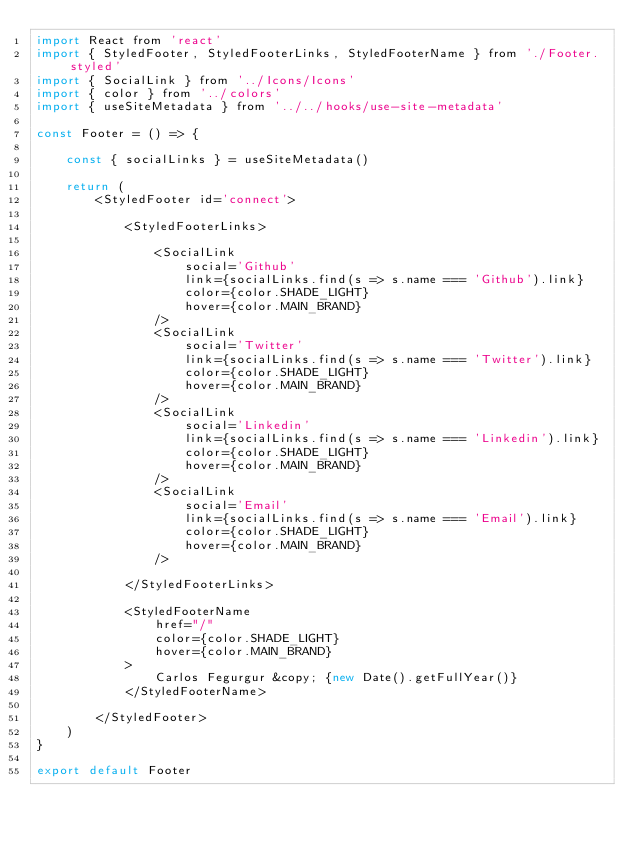<code> <loc_0><loc_0><loc_500><loc_500><_JavaScript_>import React from 'react'
import { StyledFooter, StyledFooterLinks, StyledFooterName } from './Footer.styled'
import { SocialLink } from '../Icons/Icons'
import { color } from '../colors'
import { useSiteMetadata } from '../../hooks/use-site-metadata'

const Footer = () => {

	const { socialLinks } = useSiteMetadata()

	return (
		<StyledFooter id='connect'>

			<StyledFooterLinks>

				<SocialLink
					social='Github'
					link={socialLinks.find(s => s.name === 'Github').link}
					color={color.SHADE_LIGHT}
					hover={color.MAIN_BRAND}
				/>
				<SocialLink
					social='Twitter'
					link={socialLinks.find(s => s.name === 'Twitter').link}
					color={color.SHADE_LIGHT}
					hover={color.MAIN_BRAND}
				/>
				<SocialLink
					social='Linkedin'
					link={socialLinks.find(s => s.name === 'Linkedin').link}
					color={color.SHADE_LIGHT}
					hover={color.MAIN_BRAND}
				/>
				<SocialLink
					social='Email'
					link={socialLinks.find(s => s.name === 'Email').link}
					color={color.SHADE_LIGHT}
					hover={color.MAIN_BRAND}
				/>

			</StyledFooterLinks>

			<StyledFooterName
				href="/"
				color={color.SHADE_LIGHT}
				hover={color.MAIN_BRAND}
			>
				Carlos Fegurgur &copy; {new Date().getFullYear()}
			</StyledFooterName>

		</StyledFooter>
	)
}

export default Footer</code> 